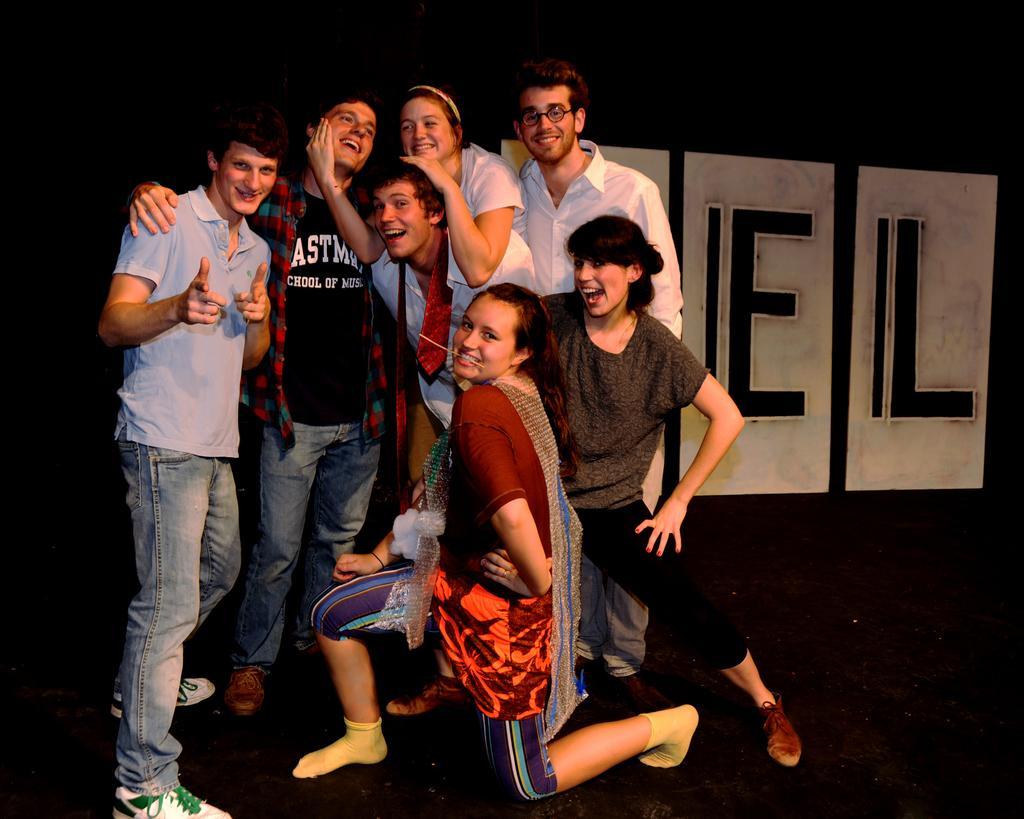Please provide a concise description of this image. In this picture we can see a group of people on the path and a woman is in squat position. Behind the people there is a dark background. 